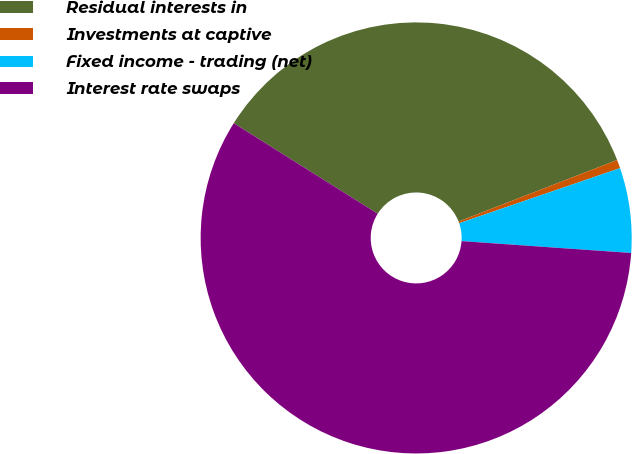<chart> <loc_0><loc_0><loc_500><loc_500><pie_chart><fcel>Residual interests in<fcel>Investments at captive<fcel>Fixed income - trading (net)<fcel>Interest rate swaps<nl><fcel>35.18%<fcel>0.64%<fcel>6.36%<fcel>57.83%<nl></chart> 